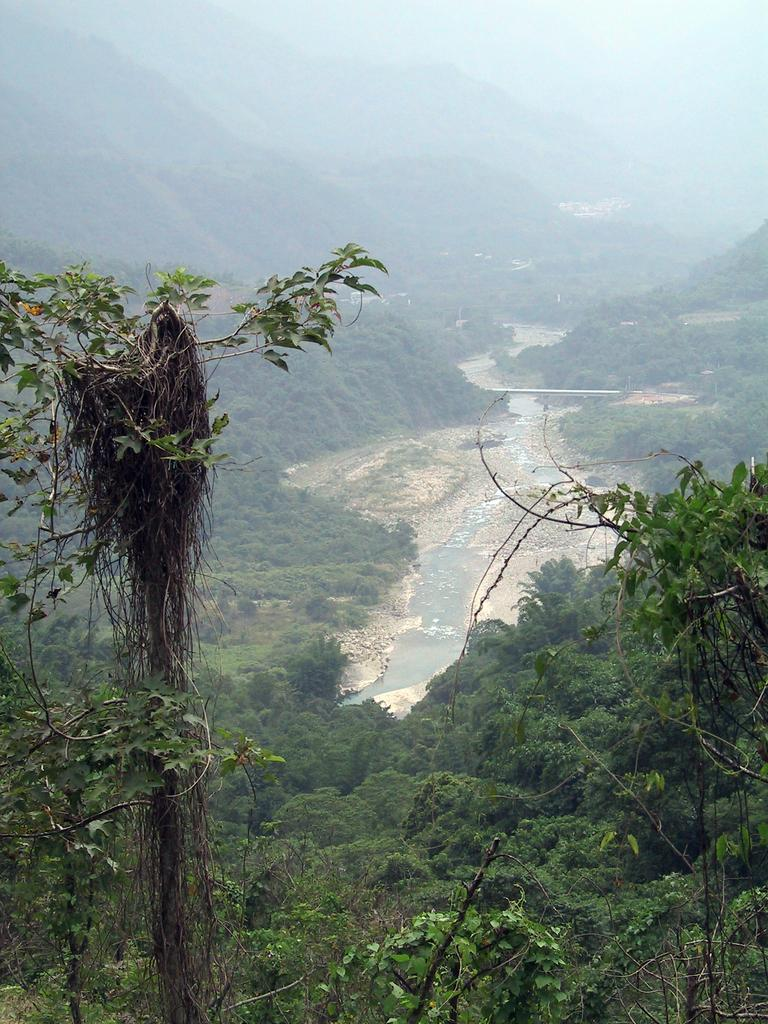What type of vegetation can be seen in the image? There are trees in the image. What is the color of the trees? The trees are green in color. What else can be seen besides the trees in the image? There is water, ground, mountains, fog, and the sky visible in the image. Can you describe the background of the image? The background of the image includes mountains, fog, and the sky. What type of paint is being used by the tramp in the image? There is no tramp or paint present in the image. What color is the glove worn by the tramp in the image? There is no tramp or glove present in the image. 